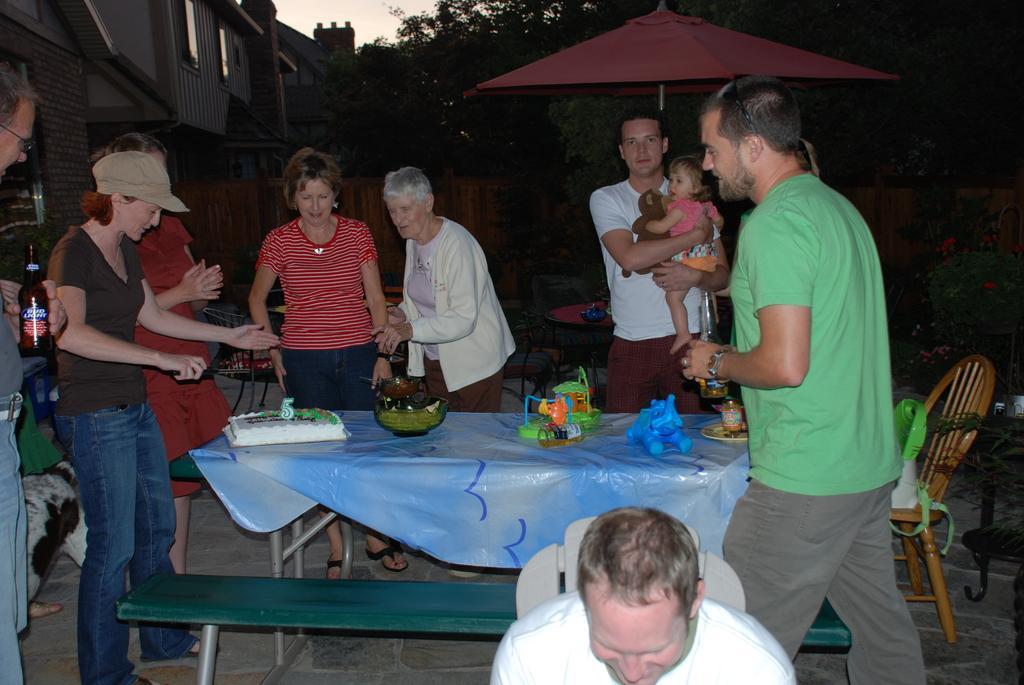Describe this image in one or two sentences. At the top we can see sky. On the background we can see building, trees. Here we can see persons standing near to the table and on the table we can see cake, bowl, toys. We can see this man standing and holding a baby with his hands under the umbrella. 